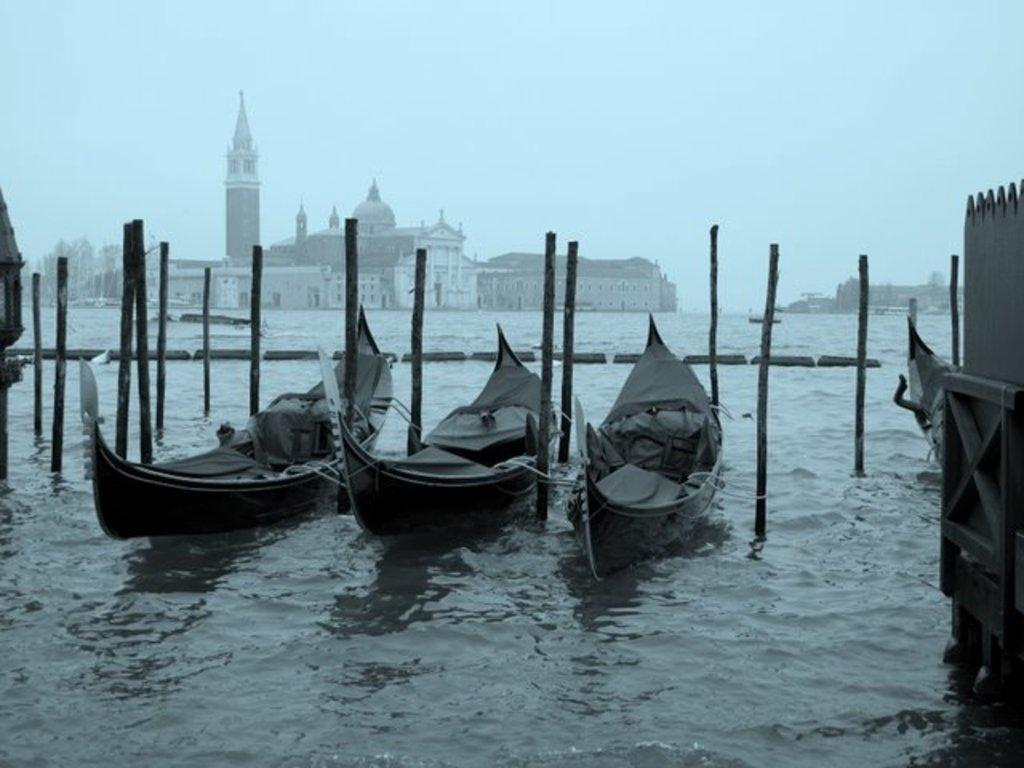What type of structures can be seen in the image? There are buildings in the image. What is present on the water in the image? There are boats on the river in the image. What objects are made of wood in the image? There are wooden poles in the image. What part of the natural environment is visible in the image? The sky is visible in the image. Can you see any magic happening in the image? There is no magic present in the image. Is your uncle in the image? Your uncle is not mentioned or visible in the image. 